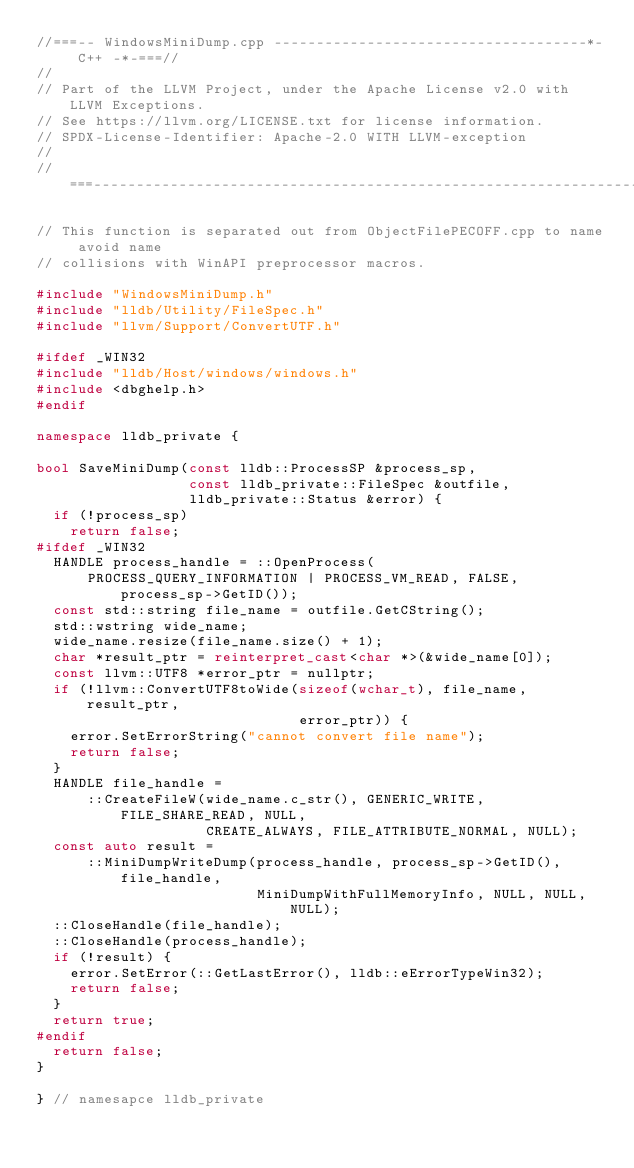<code> <loc_0><loc_0><loc_500><loc_500><_C++_>//===-- WindowsMiniDump.cpp -------------------------------------*- C++ -*-===//
//
// Part of the LLVM Project, under the Apache License v2.0 with LLVM Exceptions.
// See https://llvm.org/LICENSE.txt for license information.
// SPDX-License-Identifier: Apache-2.0 WITH LLVM-exception
//
//===----------------------------------------------------------------------===//

// This function is separated out from ObjectFilePECOFF.cpp to name avoid name
// collisions with WinAPI preprocessor macros.

#include "WindowsMiniDump.h"
#include "lldb/Utility/FileSpec.h"
#include "llvm/Support/ConvertUTF.h"

#ifdef _WIN32
#include "lldb/Host/windows/windows.h"
#include <dbghelp.h>
#endif

namespace lldb_private {

bool SaveMiniDump(const lldb::ProcessSP &process_sp,
                  const lldb_private::FileSpec &outfile,
                  lldb_private::Status &error) {
  if (!process_sp)
    return false;
#ifdef _WIN32
  HANDLE process_handle = ::OpenProcess(
      PROCESS_QUERY_INFORMATION | PROCESS_VM_READ, FALSE, process_sp->GetID());
  const std::string file_name = outfile.GetCString();
  std::wstring wide_name;
  wide_name.resize(file_name.size() + 1);
  char *result_ptr = reinterpret_cast<char *>(&wide_name[0]);
  const llvm::UTF8 *error_ptr = nullptr;
  if (!llvm::ConvertUTF8toWide(sizeof(wchar_t), file_name, result_ptr,
                               error_ptr)) {
    error.SetErrorString("cannot convert file name");
    return false;
  }
  HANDLE file_handle =
      ::CreateFileW(wide_name.c_str(), GENERIC_WRITE, FILE_SHARE_READ, NULL,
                    CREATE_ALWAYS, FILE_ATTRIBUTE_NORMAL, NULL);
  const auto result =
      ::MiniDumpWriteDump(process_handle, process_sp->GetID(), file_handle,
                          MiniDumpWithFullMemoryInfo, NULL, NULL, NULL);
  ::CloseHandle(file_handle);
  ::CloseHandle(process_handle);
  if (!result) {
    error.SetError(::GetLastError(), lldb::eErrorTypeWin32);
    return false;
  }
  return true;
#endif
  return false;
}

} // namesapce lldb_private
</code> 